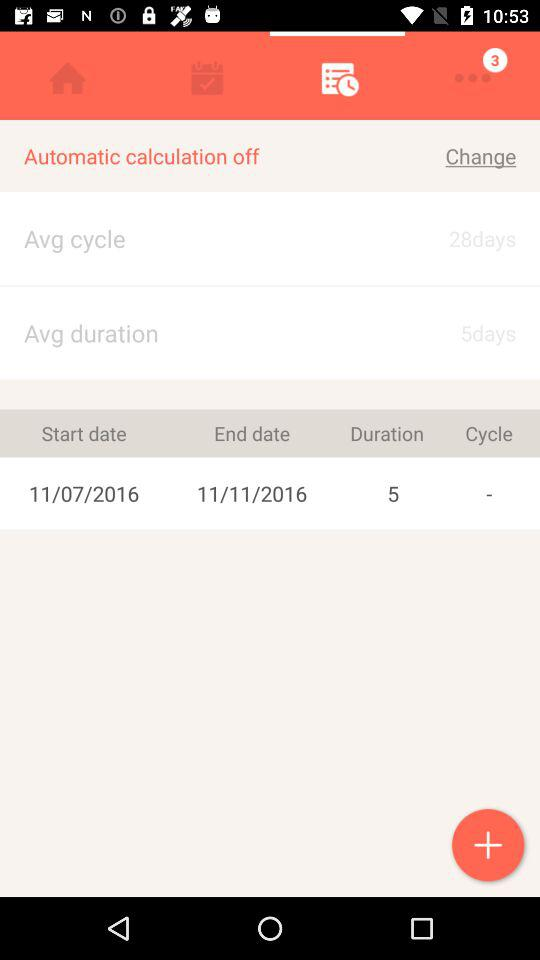What is the start date? The start date is 11/07/2016. 